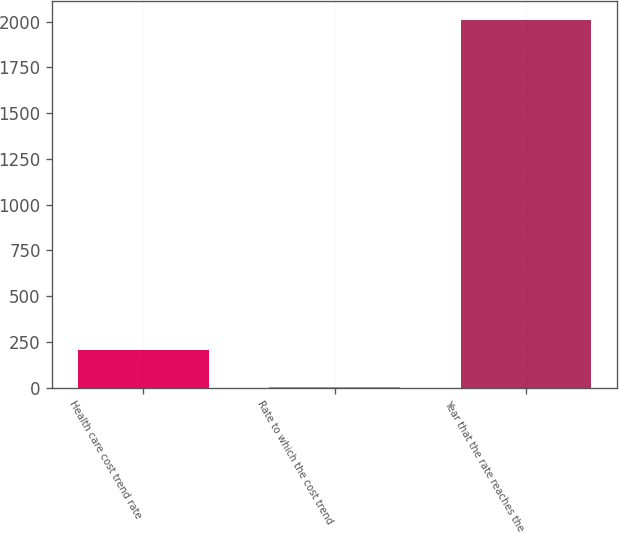Convert chart to OTSL. <chart><loc_0><loc_0><loc_500><loc_500><bar_chart><fcel>Health care cost trend rate<fcel>Rate to which the cost trend<fcel>Year that the rate reaches the<nl><fcel>205.15<fcel>4.5<fcel>2011<nl></chart> 